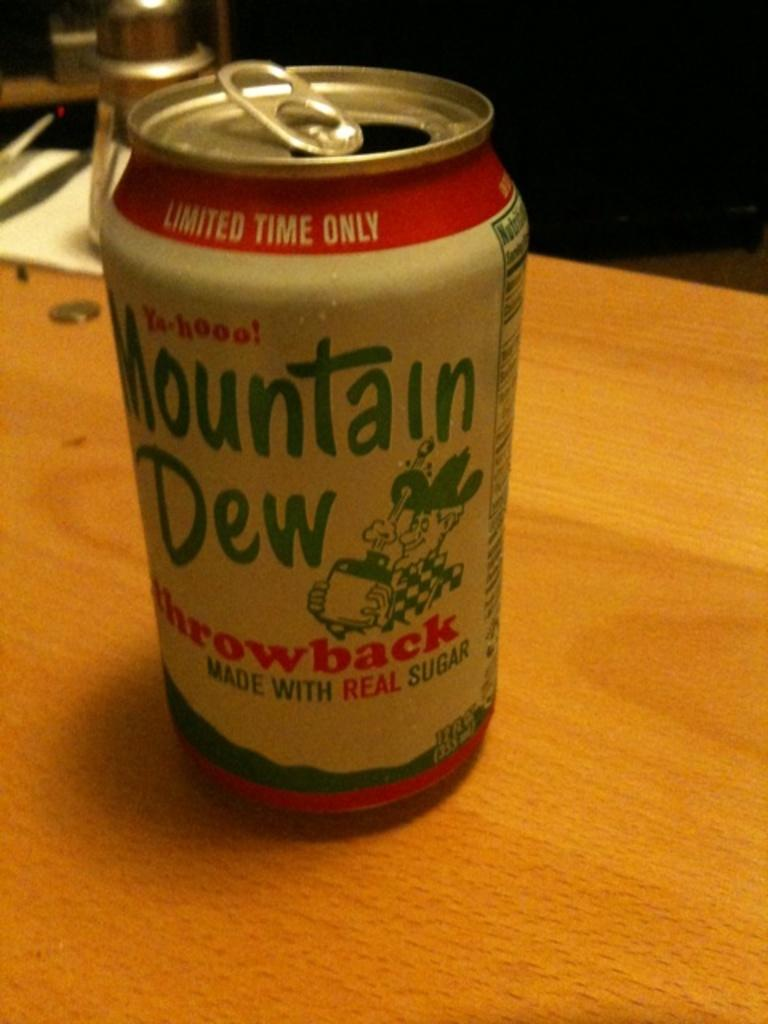Provide a one-sentence caption for the provided image. A can of Mountain Dew is a special throwback edition with a retro design. 